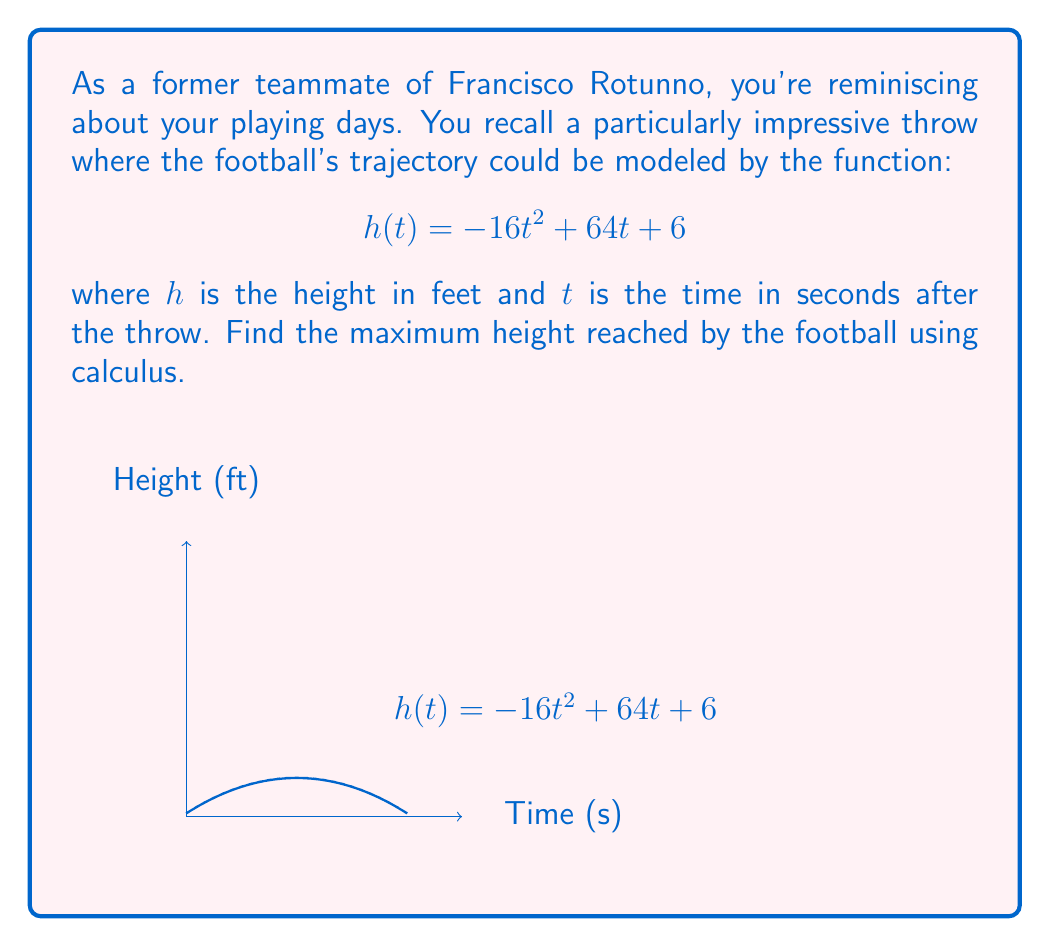Provide a solution to this math problem. To find the maximum height of the football's trajectory, we need to follow these steps:

1) The maximum height occurs at the vertex of the parabola, which corresponds to the point where the derivative of $h(t)$ equals zero.

2) Let's find the derivative of $h(t)$:
   $$h'(t) = \frac{d}{dt}(-16t^2 + 64t + 6) = -32t + 64$$

3) Set $h'(t) = 0$ and solve for $t$:
   $$-32t + 64 = 0$$
   $$-32t = -64$$
   $$t = 2$$

4) This critical point $t = 2$ gives us the time when the football reaches its maximum height.

5) To find the maximum height, we substitute $t = 2$ into the original function:
   $$h(2) = -16(2)^2 + 64(2) + 6$$
   $$= -16(4) + 128 + 6$$
   $$= -64 + 128 + 6$$
   $$= 70$$

Therefore, the maximum height reached by the football is 70 feet.
Answer: 70 feet 